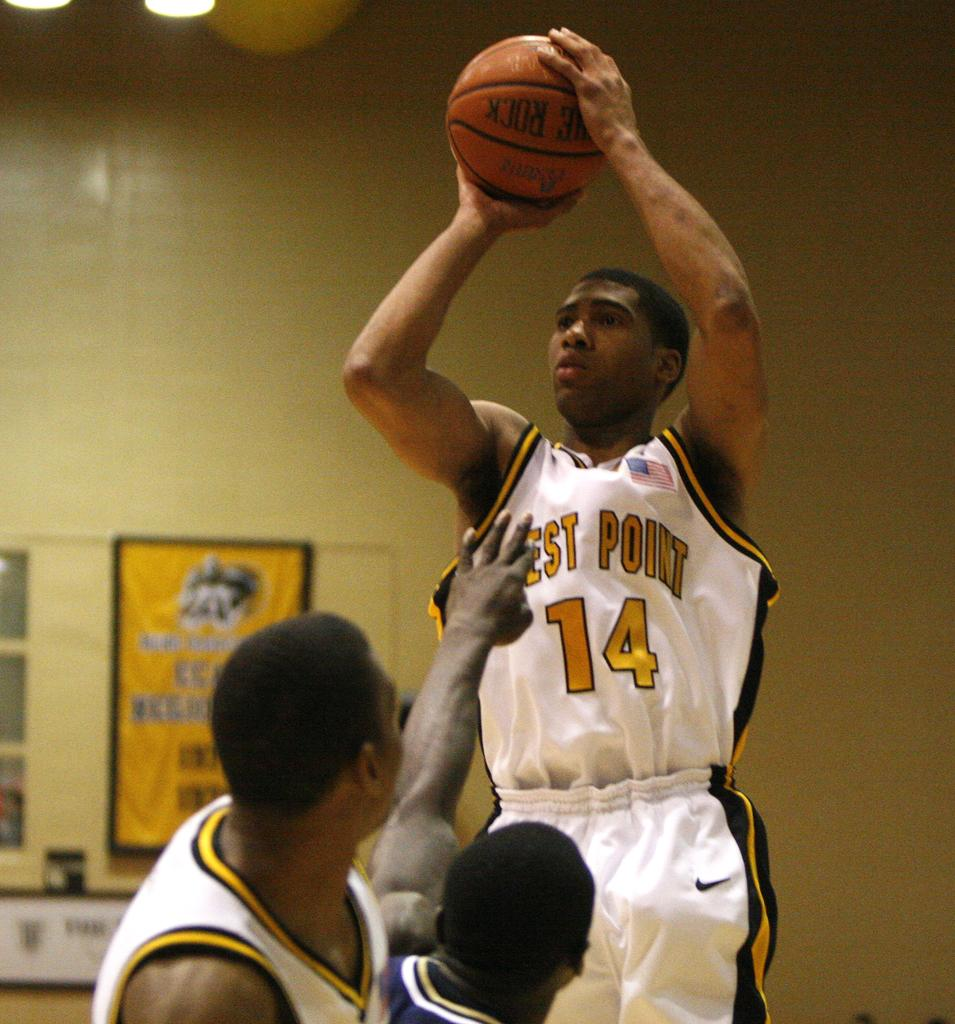<image>
Give a short and clear explanation of the subsequent image. The number 14 player from the West Point team is jumping up to take a shot at the basket. 